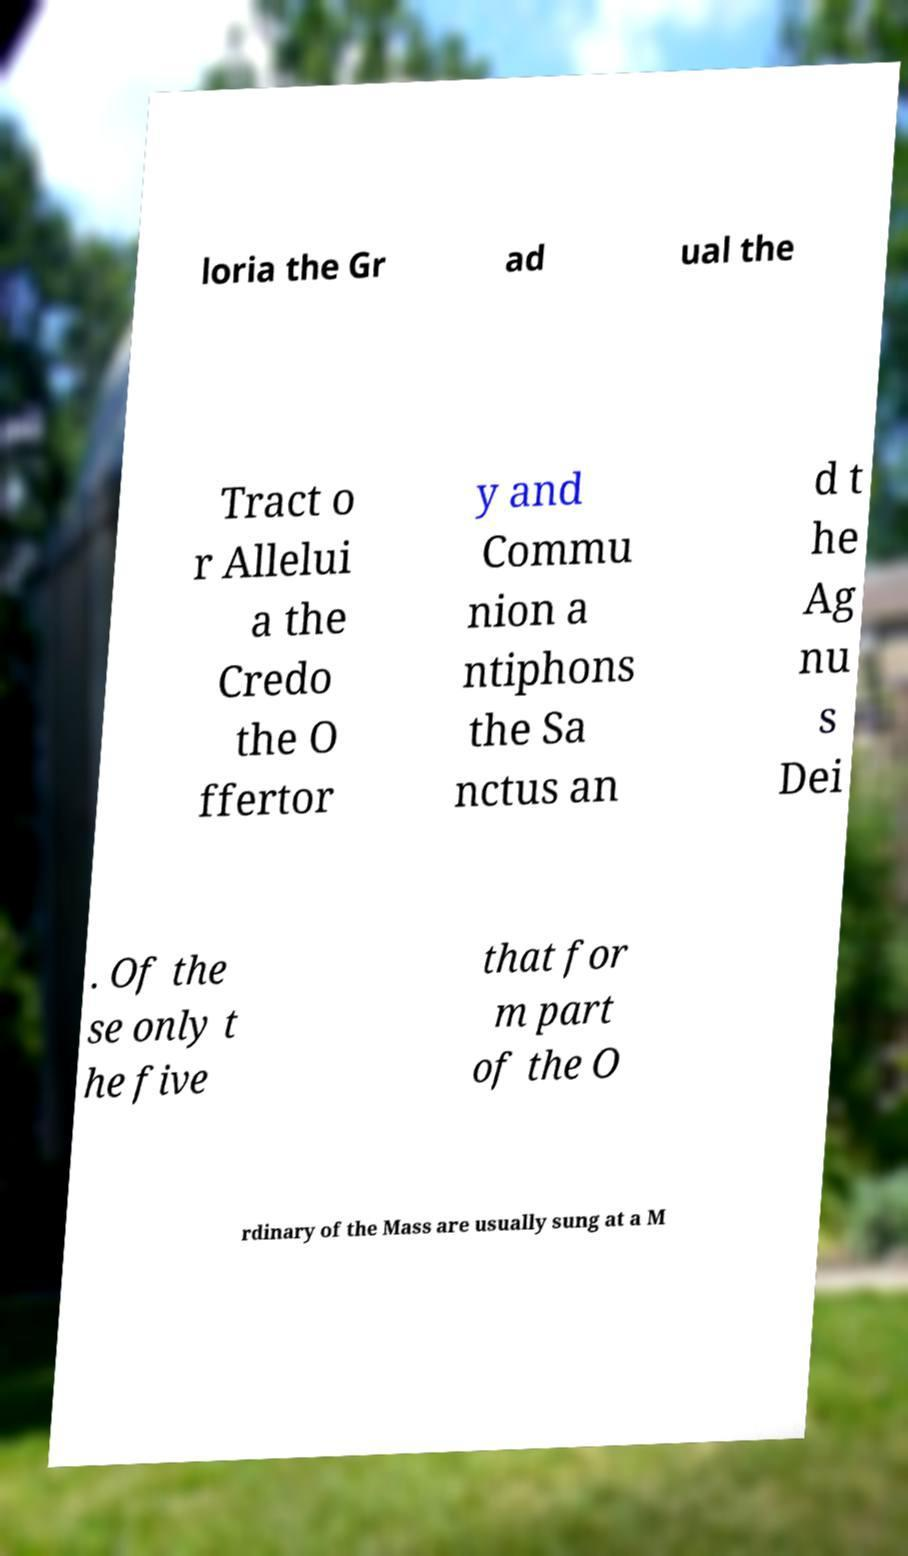Please read and relay the text visible in this image. What does it say? loria the Gr ad ual the Tract o r Allelui a the Credo the O ffertor y and Commu nion a ntiphons the Sa nctus an d t he Ag nu s Dei . Of the se only t he five that for m part of the O rdinary of the Mass are usually sung at a M 